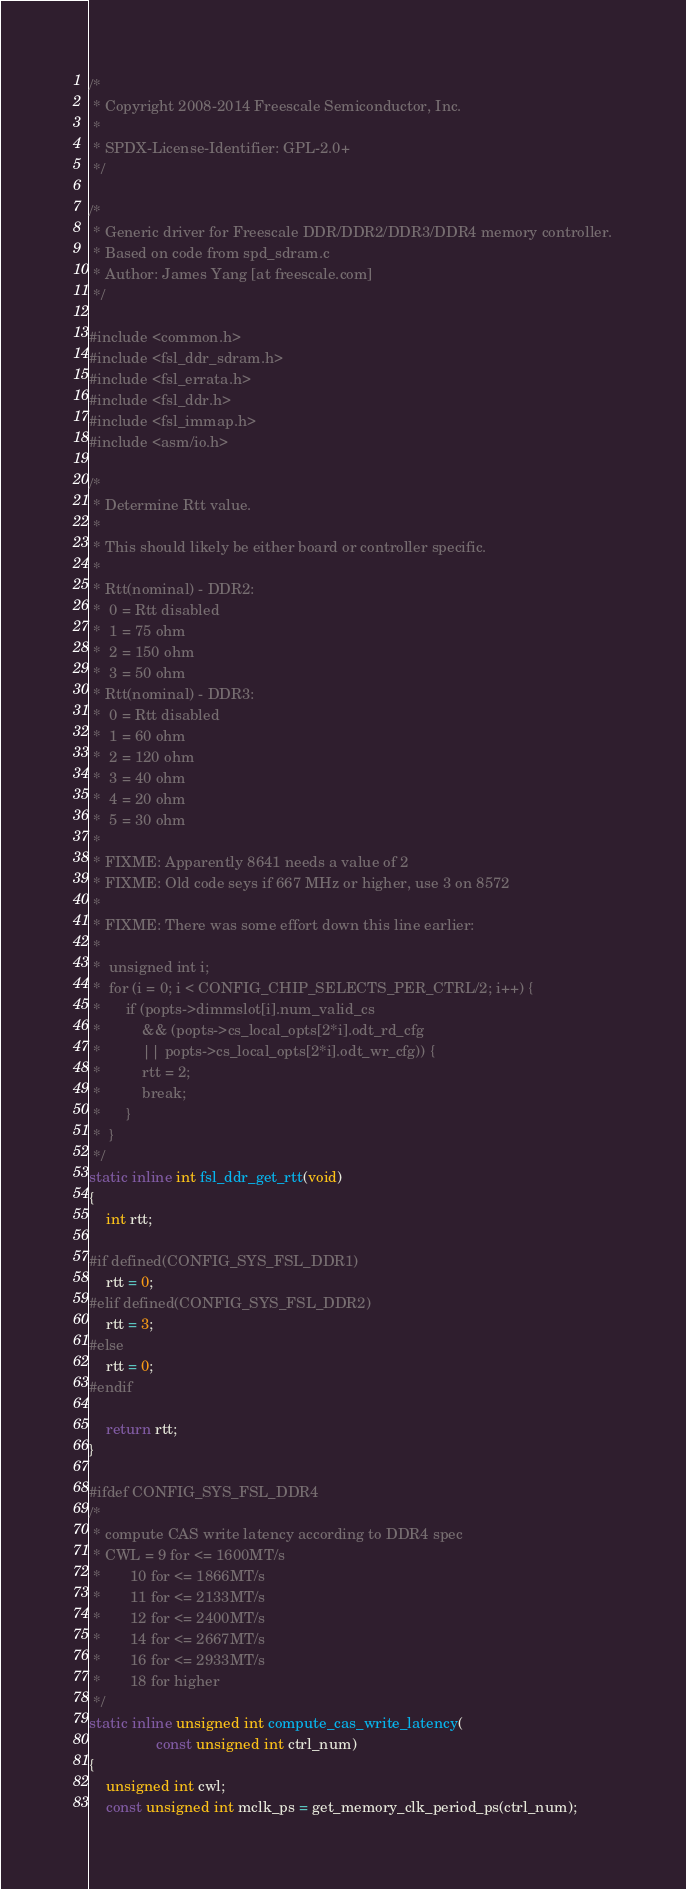Convert code to text. <code><loc_0><loc_0><loc_500><loc_500><_C_>/*
 * Copyright 2008-2014 Freescale Semiconductor, Inc.
 *
 * SPDX-License-Identifier:	GPL-2.0+
 */

/*
 * Generic driver for Freescale DDR/DDR2/DDR3/DDR4 memory controller.
 * Based on code from spd_sdram.c
 * Author: James Yang [at freescale.com]
 */

#include <common.h>
#include <fsl_ddr_sdram.h>
#include <fsl_errata.h>
#include <fsl_ddr.h>
#include <fsl_immap.h>
#include <asm/io.h>

/*
 * Determine Rtt value.
 *
 * This should likely be either board or controller specific.
 *
 * Rtt(nominal) - DDR2:
 *	0 = Rtt disabled
 *	1 = 75 ohm
 *	2 = 150 ohm
 *	3 = 50 ohm
 * Rtt(nominal) - DDR3:
 *	0 = Rtt disabled
 *	1 = 60 ohm
 *	2 = 120 ohm
 *	3 = 40 ohm
 *	4 = 20 ohm
 *	5 = 30 ohm
 *
 * FIXME: Apparently 8641 needs a value of 2
 * FIXME: Old code seys if 667 MHz or higher, use 3 on 8572
 *
 * FIXME: There was some effort down this line earlier:
 *
 *	unsigned int i;
 *	for (i = 0; i < CONFIG_CHIP_SELECTS_PER_CTRL/2; i++) {
 *		if (popts->dimmslot[i].num_valid_cs
 *		    && (popts->cs_local_opts[2*i].odt_rd_cfg
 *			|| popts->cs_local_opts[2*i].odt_wr_cfg)) {
 *			rtt = 2;
 *			break;
 *		}
 *	}
 */
static inline int fsl_ddr_get_rtt(void)
{
	int rtt;

#if defined(CONFIG_SYS_FSL_DDR1)
	rtt = 0;
#elif defined(CONFIG_SYS_FSL_DDR2)
	rtt = 3;
#else
	rtt = 0;
#endif

	return rtt;
}

#ifdef CONFIG_SYS_FSL_DDR4
/*
 * compute CAS write latency according to DDR4 spec
 * CWL = 9 for <= 1600MT/s
 *       10 for <= 1866MT/s
 *       11 for <= 2133MT/s
 *       12 for <= 2400MT/s
 *       14 for <= 2667MT/s
 *       16 for <= 2933MT/s
 *       18 for higher
 */
static inline unsigned int compute_cas_write_latency(
				const unsigned int ctrl_num)
{
	unsigned int cwl;
	const unsigned int mclk_ps = get_memory_clk_period_ps(ctrl_num);</code> 